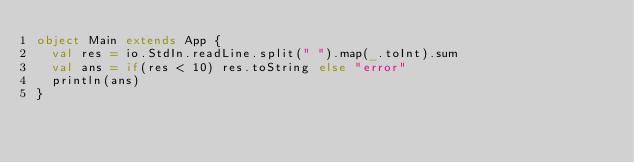<code> <loc_0><loc_0><loc_500><loc_500><_Scala_>object Main extends App {
  val res = io.StdIn.readLine.split(" ").map(_.toInt).sum
  val ans = if(res < 10) res.toString else "error"
  println(ans)
}</code> 